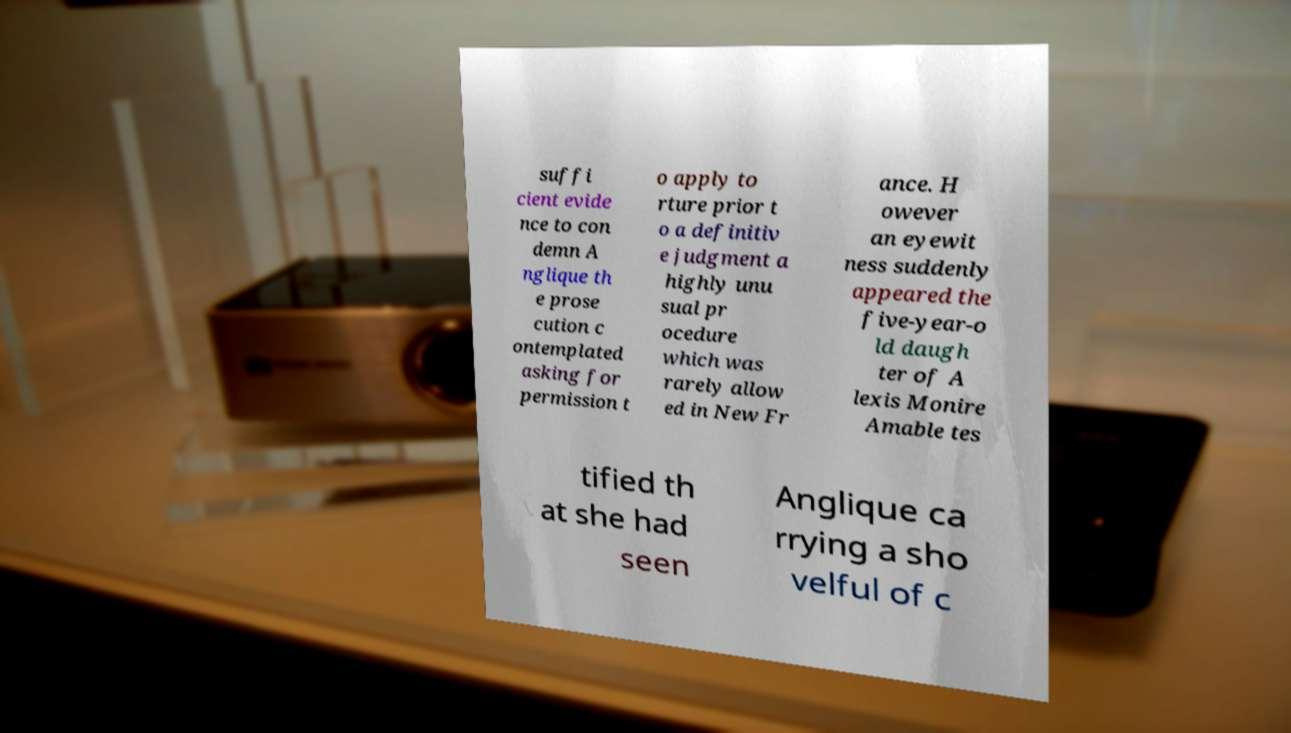Could you extract and type out the text from this image? suffi cient evide nce to con demn A nglique th e prose cution c ontemplated asking for permission t o apply to rture prior t o a definitiv e judgment a highly unu sual pr ocedure which was rarely allow ed in New Fr ance. H owever an eyewit ness suddenly appeared the five-year-o ld daugh ter of A lexis Monire Amable tes tified th at she had seen Anglique ca rrying a sho velful of c 